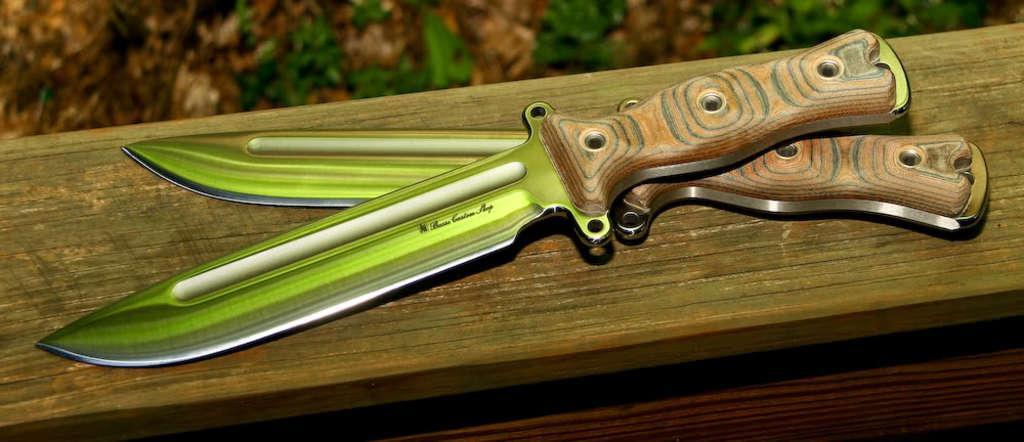Please provide a concise description of this image. In this image there are two knives on the wooden platform. 